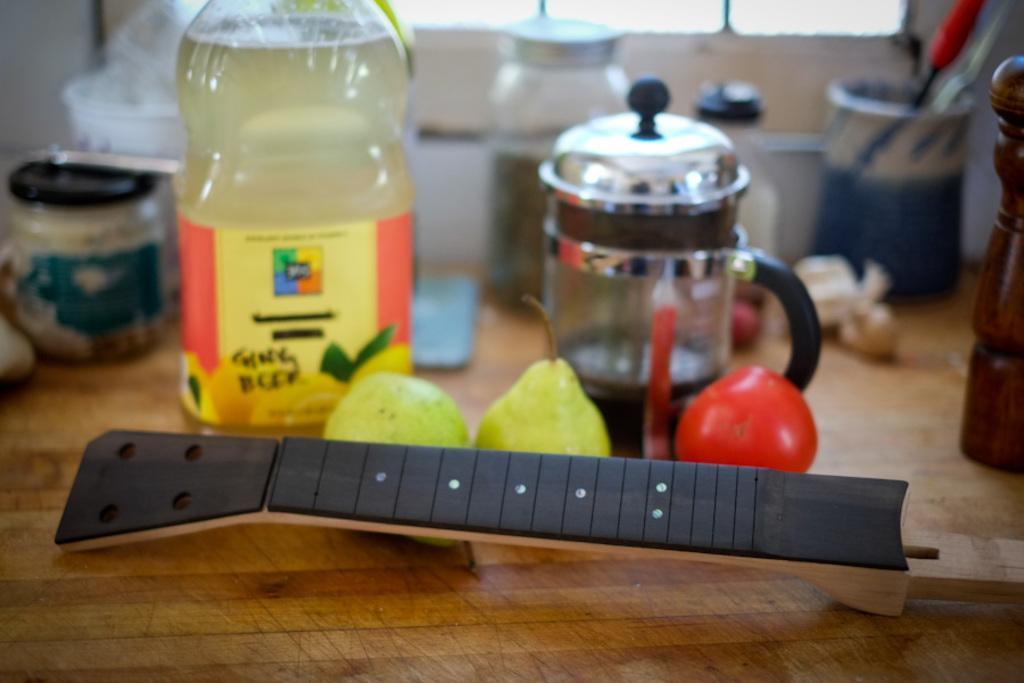Could you give a brief overview of what you see in this image? This picture shows bottles and fruits on the table 